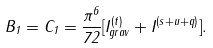Convert formula to latex. <formula><loc_0><loc_0><loc_500><loc_500>B _ { 1 } = C _ { 1 } = \frac { \pi ^ { 6 } } { 7 2 } [ I _ { g r a v } ^ { ( t ) } + I ^ { ( s + u + q ) } ] .</formula> 